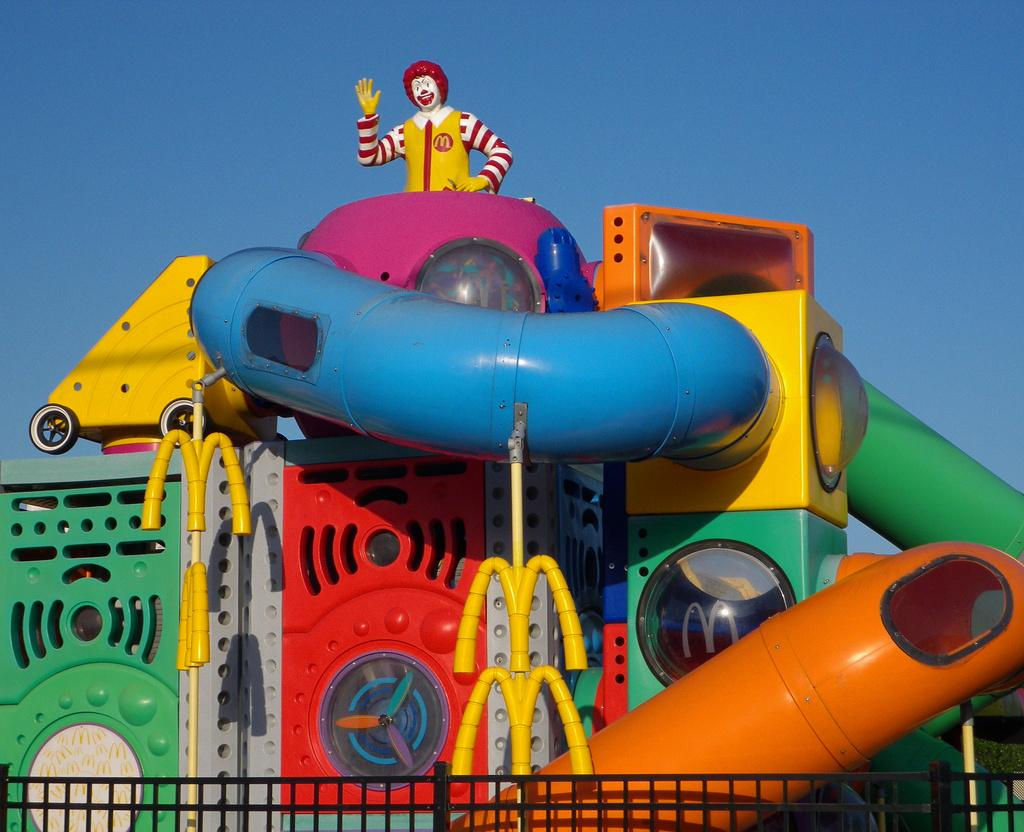What type of attraction is present in the image? There is an amusement ride in the image. What can be seen surrounding the amusement ride? There is a fence in the image. Are there any other notable features in the image? Yes, there is a statue in the image. What can be seen in the distance in the image? The sky is visible in the background of the image. What type of vest is the daughter wearing in the image? There is no daughter present in the image, and therefore no vest to describe. 